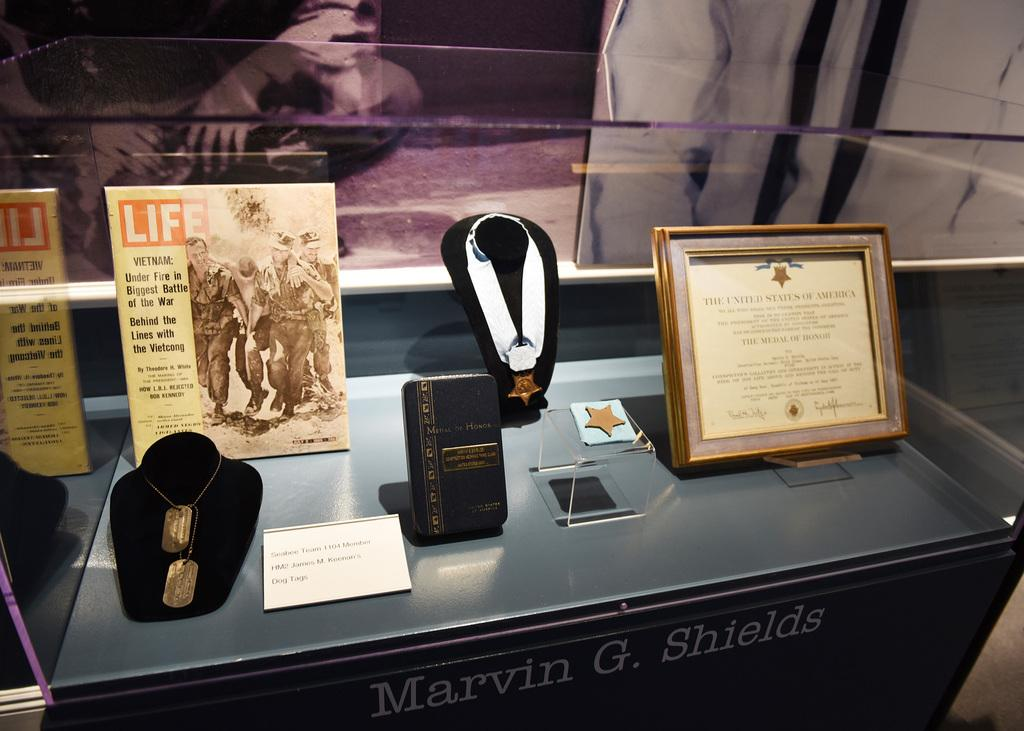What is the main object in the image? There is a showcase in the image. What items can be seen inside the showcase? The showcase contains medals and certificates. What type of seed is being used to grow a plant in the image? There is no plant or seed present in the image; it only features a showcase with medals and certificates. 